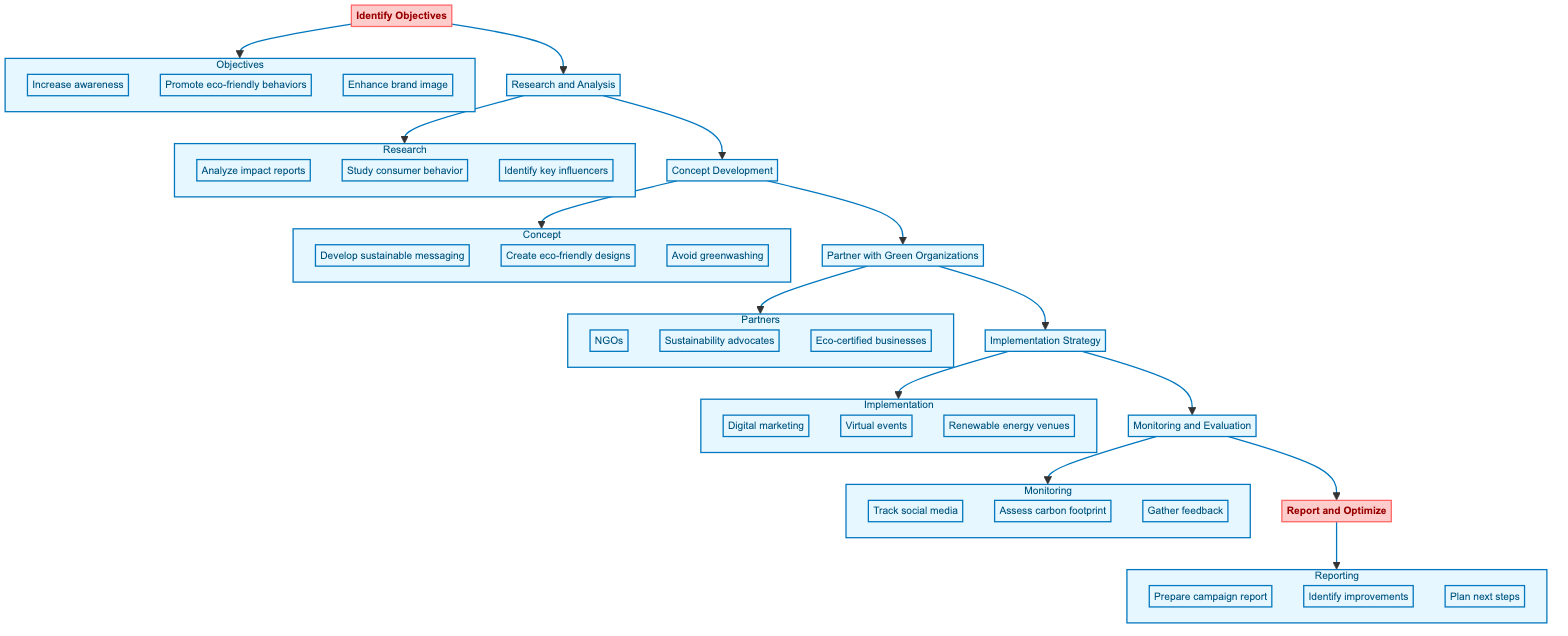What is the first step in the eco-friendly PR campaign? The first step in the diagram is to "Identify Objectives." This is shown as the initial node in the flowchart, signifying the starting point of the process.
Answer: Identify Objectives How many steps are there in total in the flowchart? By counting the main nodes connected with arrows in the flowchart, there are seven steps represented. This includes every process from the initiation to the conclusion of the campaign.
Answer: Seven Which step follows "Research and Analysis"? In the diagram, the step that follows "Research and Analysis" is "Concept Development," as indicated by the arrow leading from node B to node C.
Answer: Concept Development What are the three elements listed under the "Partner with Green Organizations" step? The three elements under this step are "Reach out to NGOs," "Engage with sustainability advocates," and "Form partnerships with eco-certified businesses." These are detailed in the associated subgraph.
Answer: Reach out to NGOs, Engage with sustainability advocates, Form partnerships with eco-certified businesses How does "Monitoring and Evaluation" relate to "Report and Optimize"? "Monitoring and Evaluation" (F) feeds directly into "Report and Optimize" (G) as the final steps in the sequence. The arrow connects F to G, indicating that evaluation informs the reporting process.
Answer: F to G What aspect does "Implementation Strategy" emphasize for the PR campaign? The "Implementation Strategy" emphasizes planning the execution of the PR campaign with a focus on eco-friendly practices, which are detailed further in the subgraph beneath that node.
Answer: Eco-friendly practices Identify one specific detail derived from the "Concept Development" step. One specific detail from "Concept Development" is to "Create visual designs using eco-friendly themes," as shown in the related subgraph outlining this step's details.
Answer: Create visual designs using eco-friendly themes Which subgraph includes an element discussing social media engagement? The subgraph titled "Monitoring" includes the element "Track social media," which discusses engaging with audiences through social media and is crucial for performance assessment in the campaign.
Answer: Monitoring What is the last step in this eco-friendly PR campaign process? The last step is "Report and Optimize," which is associated with analyzing the effectiveness of the campaign and planning future strategies. This step is clearly marked as the endpoint in the flow.
Answer: Report and Optimize 